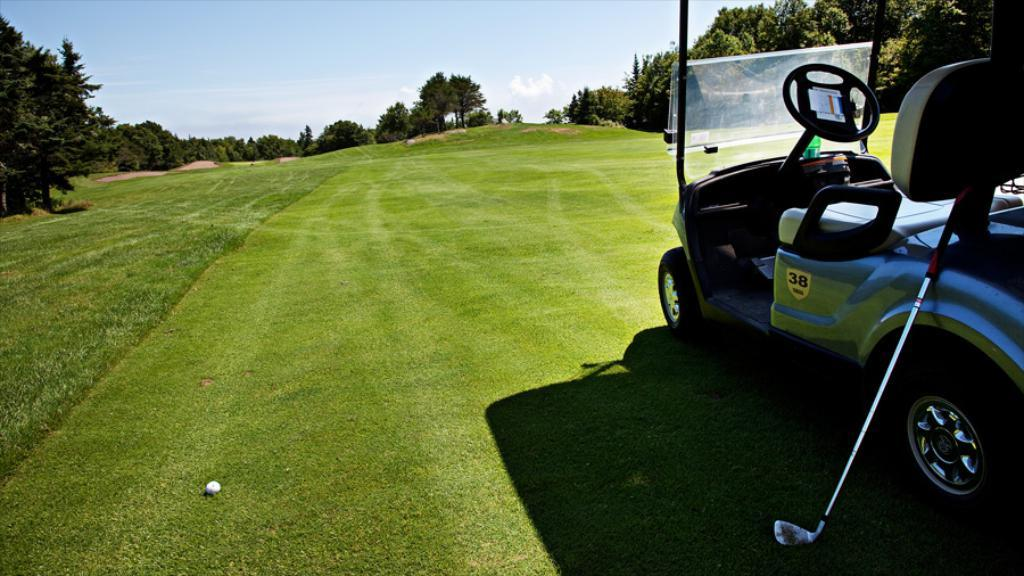What type of vehicle is in the image? There is a vehicle in the image, but the specific type is not mentioned in the facts. What object is associated with the sport of golf in the image? There is a golf stick in the image. What is on the ground near the golf stick? There is a ball on the ground in the image. What type of terrain is visible in the image? There is grass visible in the image. What type of vegetation is present in the image? There is a group of trees in the image. What is the condition of the sky in the image? The sky is visible in the image and appears cloudy. Where is the coil located in the image? There is no coil present in the image. What type of playground equipment can be seen in the image? There is no playground equipment present in the image. What type of transportation hub is visible in the image? There is no airport or any other transportation hub visible in the image. 